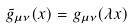Convert formula to latex. <formula><loc_0><loc_0><loc_500><loc_500>\tilde { g } _ { \mu \nu } ( x ) = g _ { \mu \nu } ( \lambda x )</formula> 